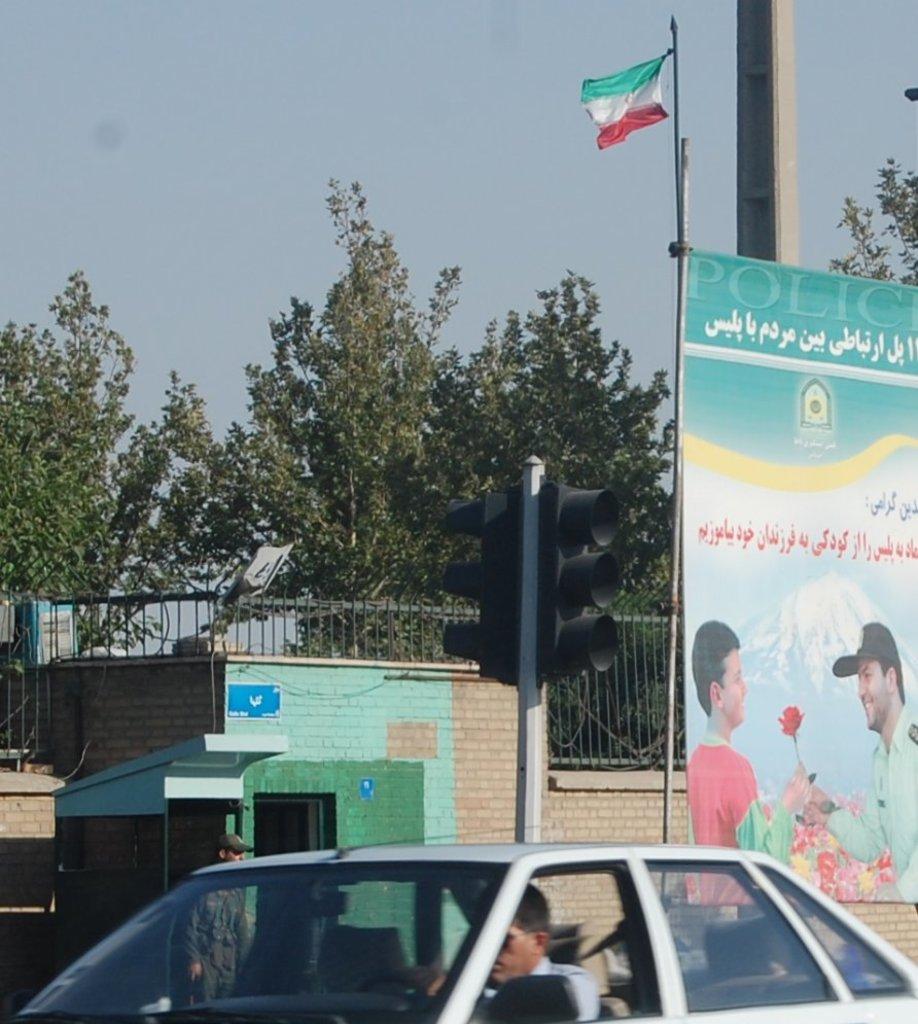Can you describe this image briefly? In the image we can see there is a car which is parked on the road and behind there is a banner of a man giving rose to another person and behind there are lot of trees and a flag which is hoisted. 